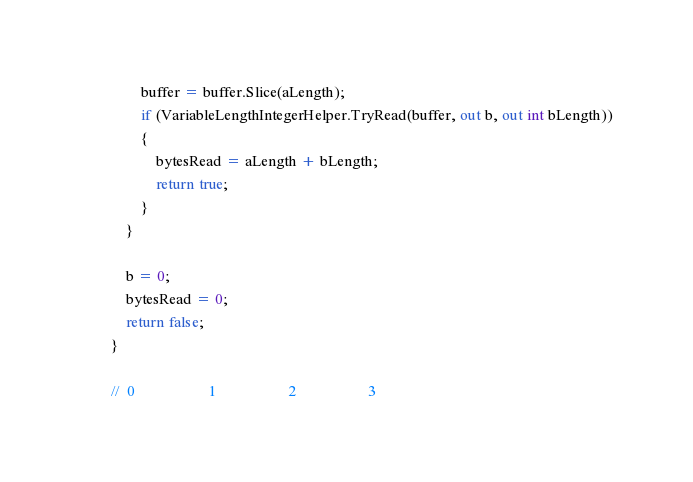Convert code to text. <code><loc_0><loc_0><loc_500><loc_500><_C#_>                buffer = buffer.Slice(aLength);
                if (VariableLengthIntegerHelper.TryRead(buffer, out b, out int bLength))
                {
                    bytesRead = aLength + bLength;
                    return true;
                }
            }

            b = 0;
            bytesRead = 0;
            return false;
        }

        //  0                   1                   2                   3</code> 